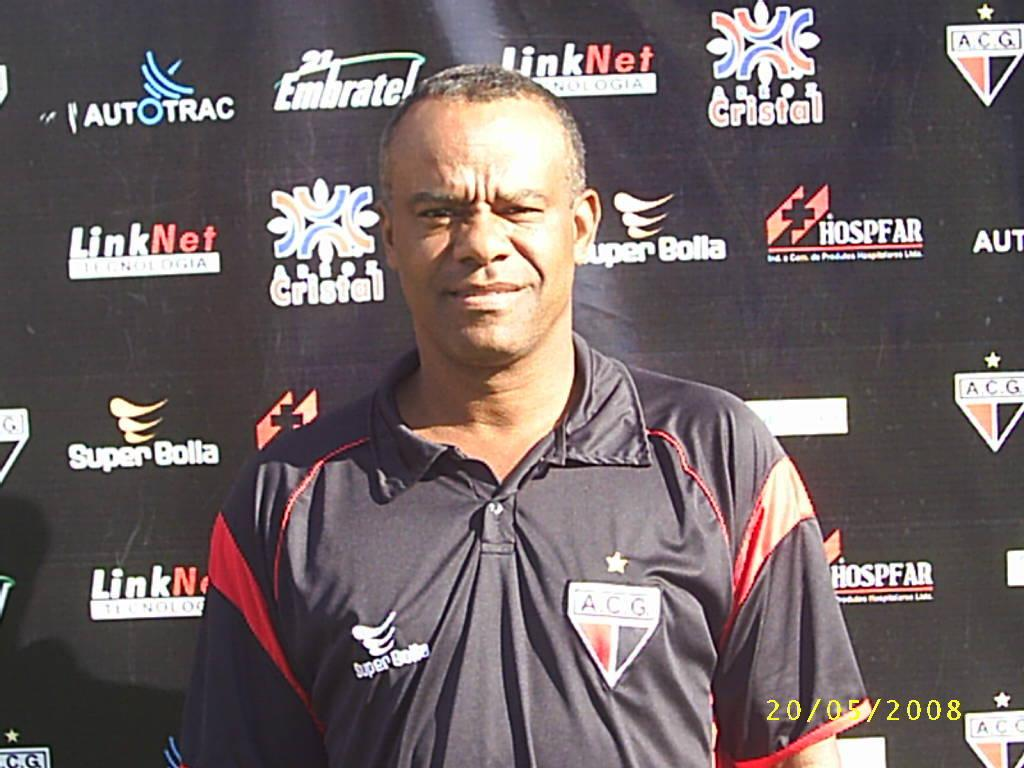<image>
Give a short and clear explanation of the subsequent image. A man in a shirt with an A C G patch poses for a picture. 